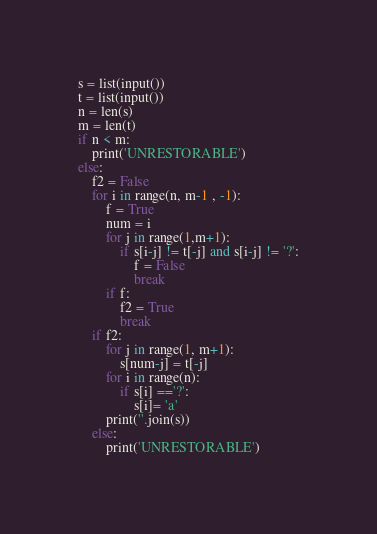Convert code to text. <code><loc_0><loc_0><loc_500><loc_500><_Python_>s = list(input())
t = list(input())
n = len(s)
m = len(t)
if n < m:
    print('UNRESTORABLE')
else:
    f2 = False
    for i in range(n, m-1 , -1):
        f = True
        num = i
        for j in range(1,m+1):
            if s[i-j] != t[-j] and s[i-j] != '?':
                f = False
                break
        if f:
            f2 = True
            break
    if f2:
        for j in range(1, m+1):
            s[num-j] = t[-j]
        for i in range(n):
            if s[i] =='?':
                s[i]= 'a'
        print(''.join(s))
    else:
        print('UNRESTORABLE')</code> 